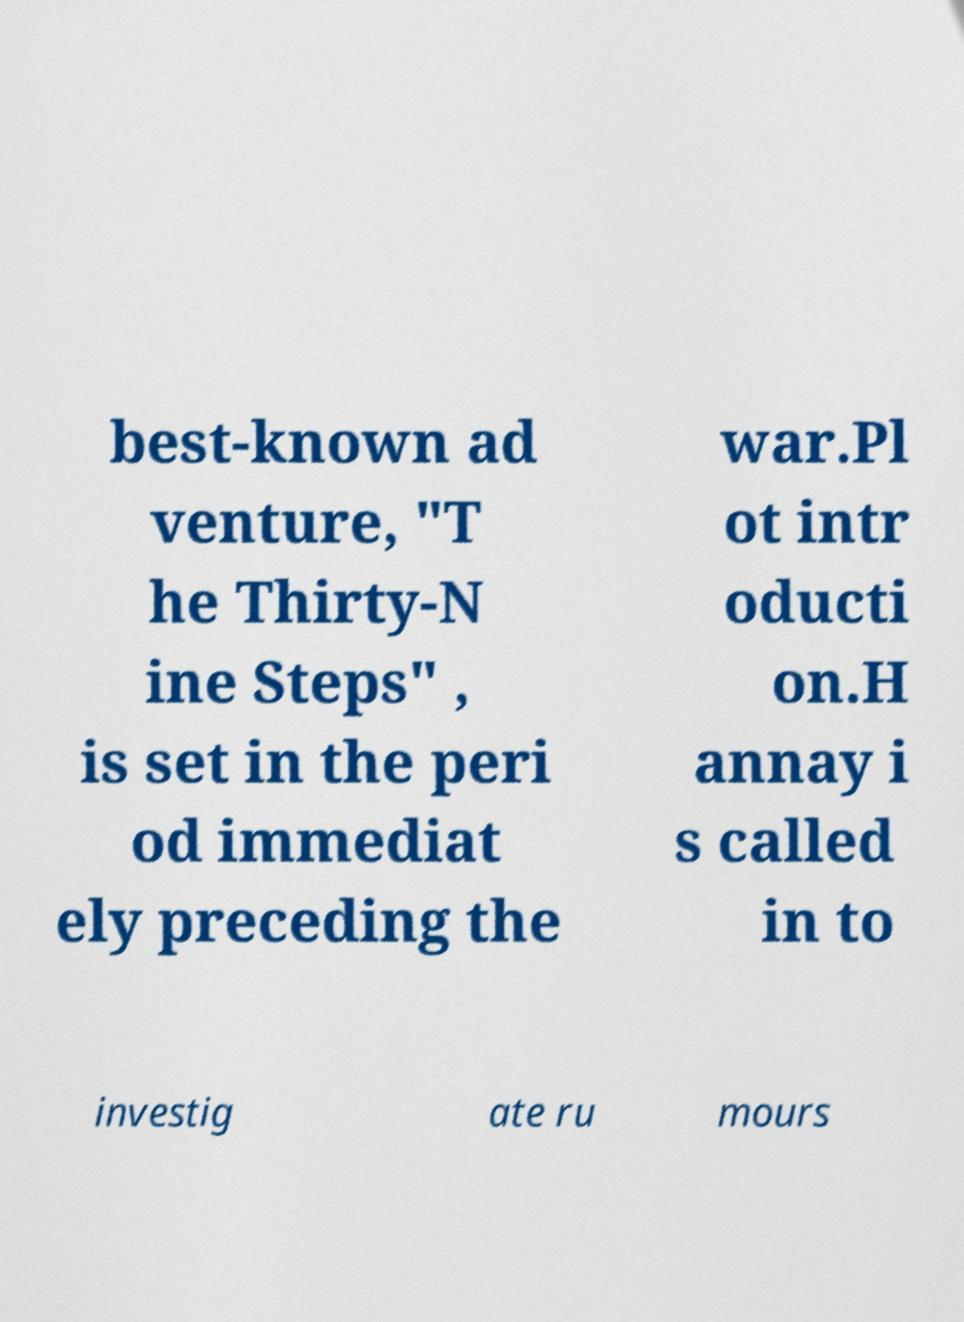Could you assist in decoding the text presented in this image and type it out clearly? best-known ad venture, "T he Thirty-N ine Steps" , is set in the peri od immediat ely preceding the war.Pl ot intr oducti on.H annay i s called in to investig ate ru mours 